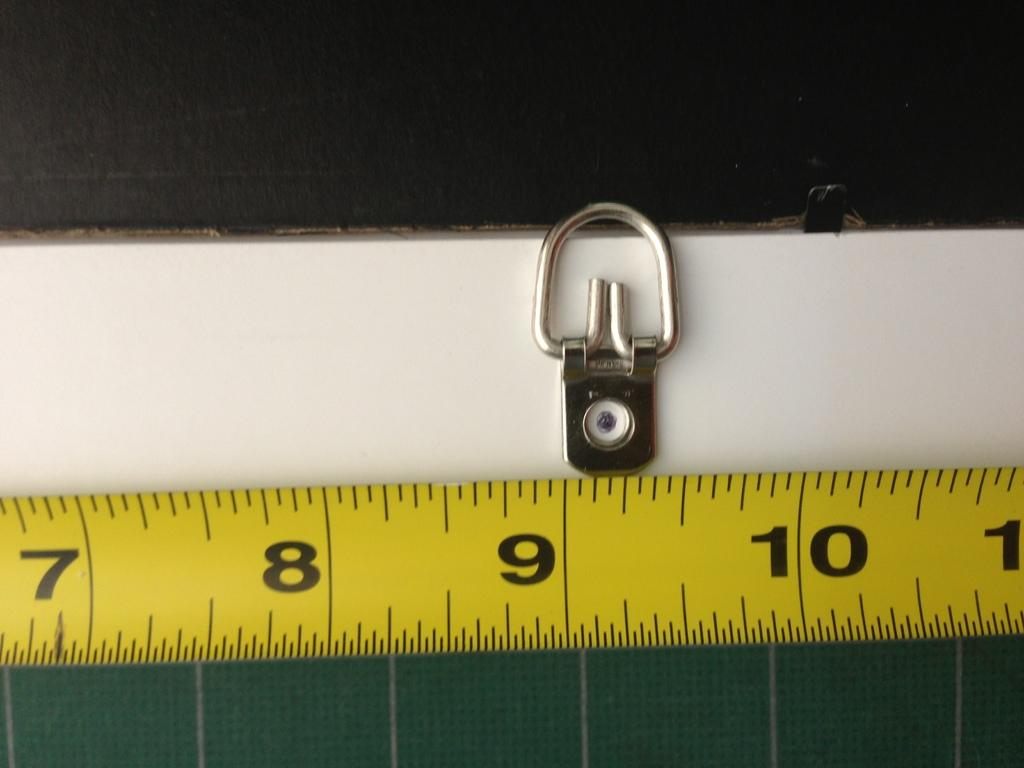<image>
Share a concise interpretation of the image provided. a measuring tape with #'s (in inches) 7, 8, 9 and 10 visible. 